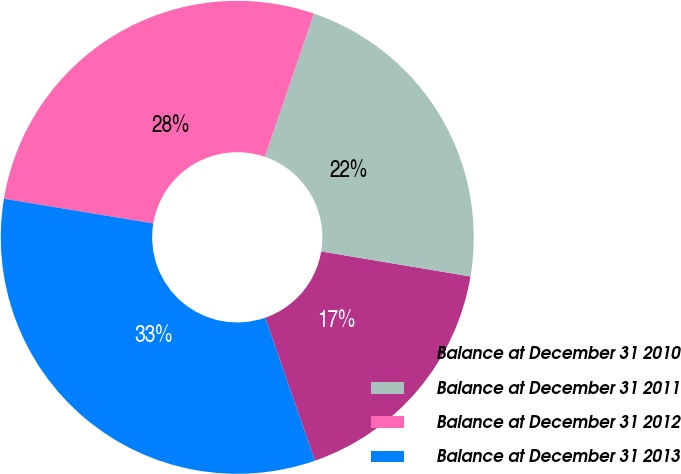Convert chart. <chart><loc_0><loc_0><loc_500><loc_500><pie_chart><fcel>Balance at December 31 2010<fcel>Balance at December 31 2011<fcel>Balance at December 31 2012<fcel>Balance at December 31 2013<nl><fcel>17.03%<fcel>22.39%<fcel>27.65%<fcel>32.93%<nl></chart> 